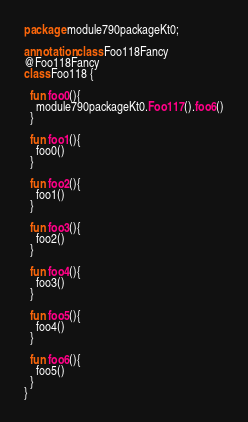Convert code to text. <code><loc_0><loc_0><loc_500><loc_500><_Kotlin_>package module790packageKt0;

annotation class Foo118Fancy
@Foo118Fancy
class Foo118 {

  fun foo0(){
    module790packageKt0.Foo117().foo6()
  }

  fun foo1(){
    foo0()
  }

  fun foo2(){
    foo1()
  }

  fun foo3(){
    foo2()
  }

  fun foo4(){
    foo3()
  }

  fun foo5(){
    foo4()
  }

  fun foo6(){
    foo5()
  }
}</code> 